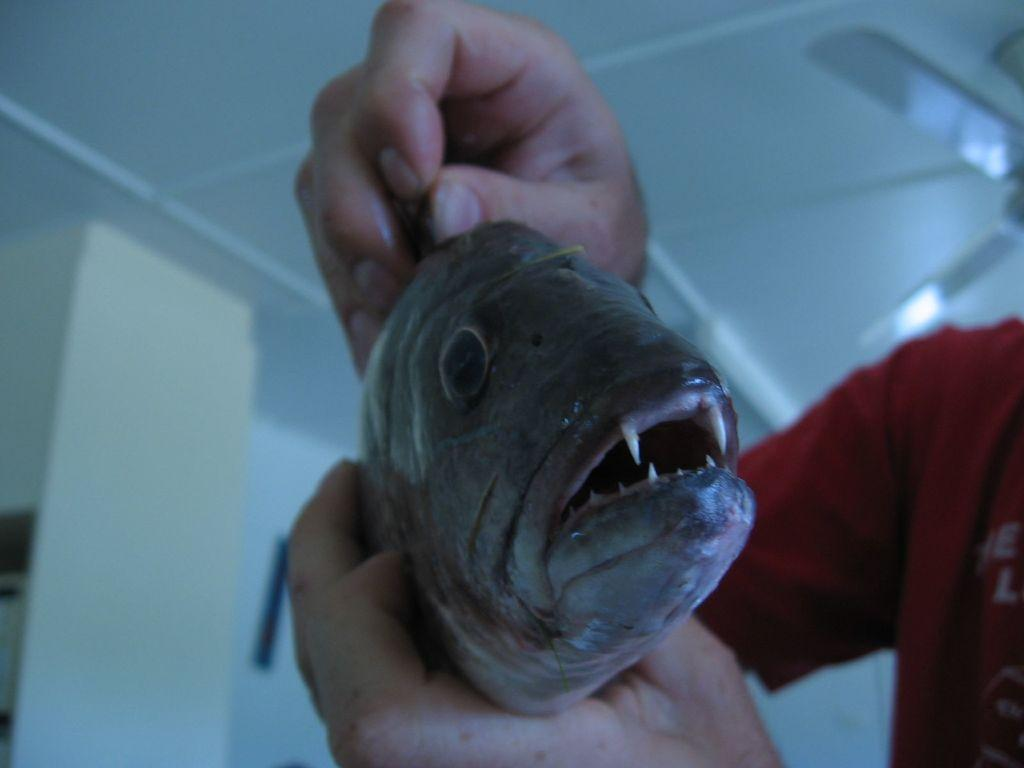Who or what is the main subject in the image? There is a person in the image. What is the person holding in their hands? The person is holding a fish in their hands. What can be seen behind the person? There is a wall behind the person. What type of appliance is attached to the ceiling in the image? There is a fan attached to the ceiling in the image. What type of cloud can be seen in the image? There are no clouds visible in the image; it is an indoor scene with a person holding a fish, a wall behind them, and a fan attached to the ceiling. 